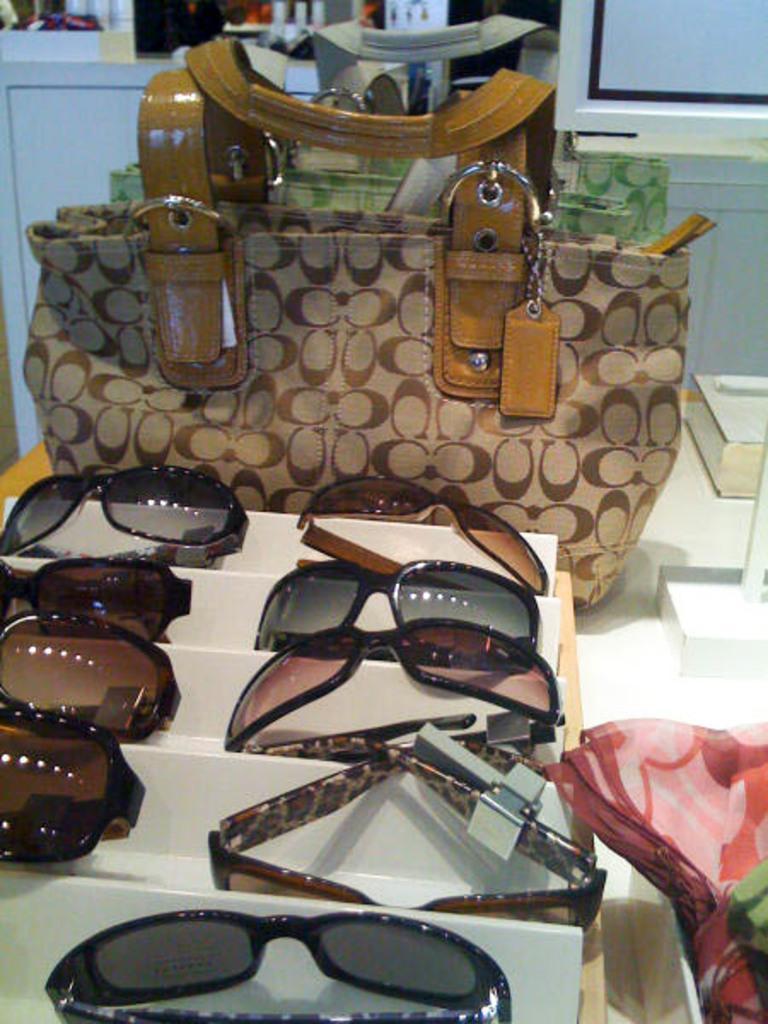In one or two sentences, can you explain what this image depicts? There is a table. There is a bag,spectacle,cloth on a table. We can see the background there is a cupboard. 